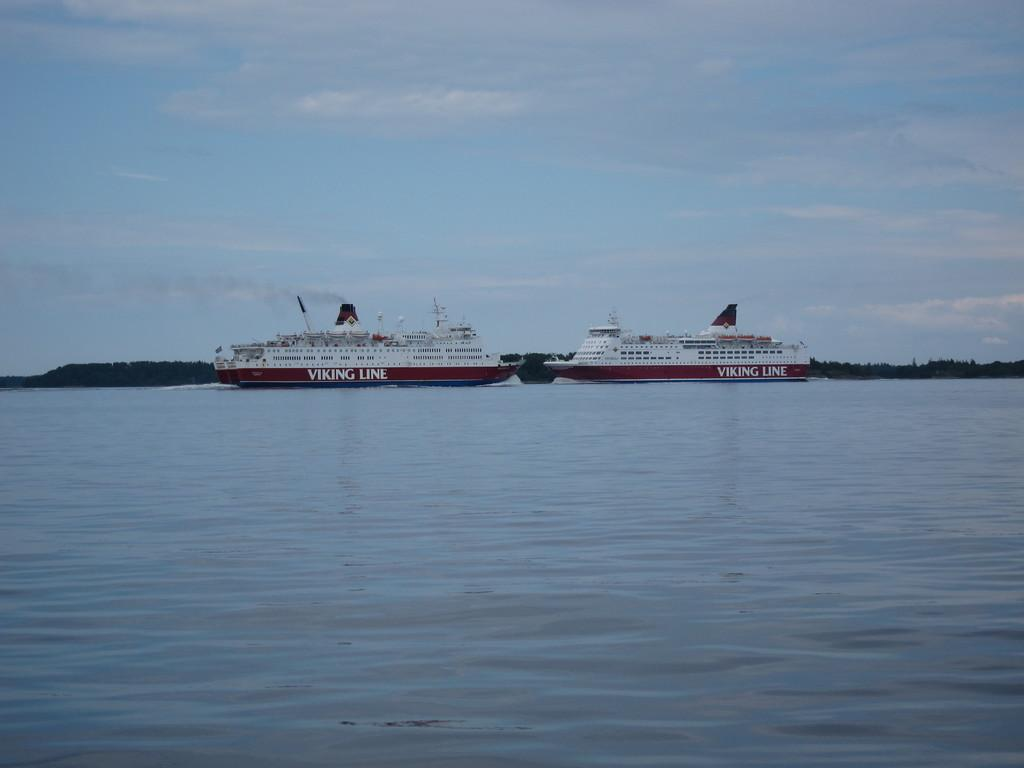What type of vehicles are in the image? There are ships in the image. Where are the ships located? The ships are on the water. What type of natural landform can be seen in the image? There are mountains visible in the image. What part of the natural environment is visible in the image? The sky is visible in the image. What type of eggnog can be seen in the image? There is no eggnog present in the image. 